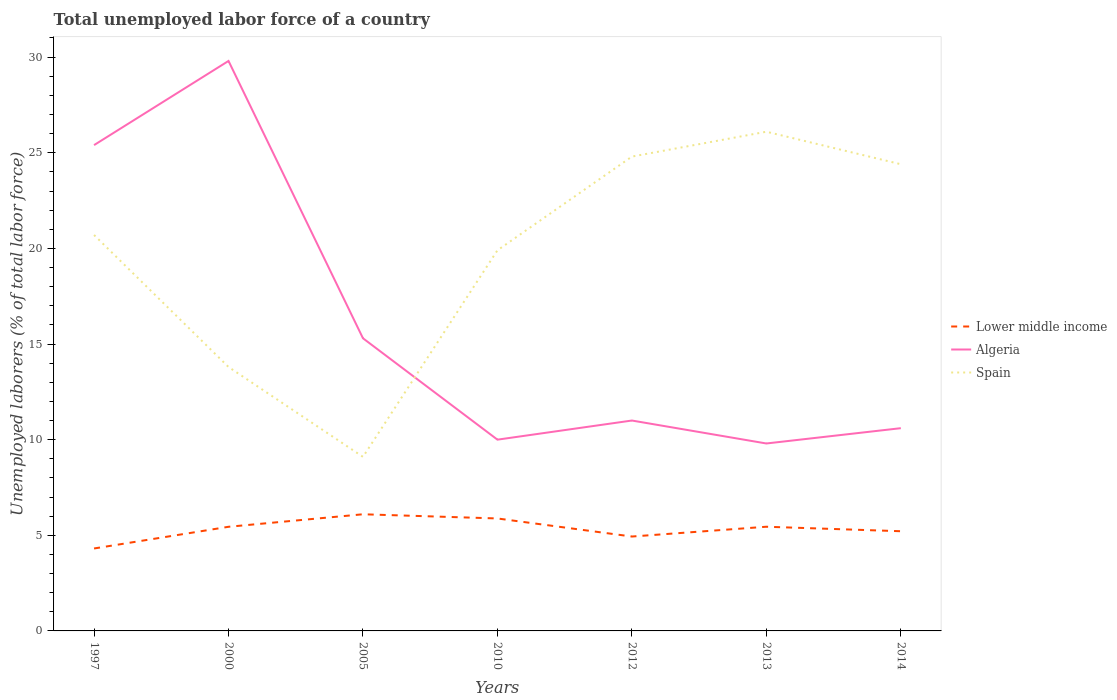Is the number of lines equal to the number of legend labels?
Ensure brevity in your answer.  Yes. Across all years, what is the maximum total unemployed labor force in Spain?
Offer a very short reply. 9.1. What is the total total unemployed labor force in Lower middle income in the graph?
Your answer should be very brief. 0.22. What is the difference between the highest and the second highest total unemployed labor force in Spain?
Provide a succinct answer. 17. What is the difference between the highest and the lowest total unemployed labor force in Algeria?
Offer a terse response. 2. How many lines are there?
Provide a short and direct response. 3. Are the values on the major ticks of Y-axis written in scientific E-notation?
Make the answer very short. No. Does the graph contain grids?
Keep it short and to the point. No. How are the legend labels stacked?
Provide a succinct answer. Vertical. What is the title of the graph?
Make the answer very short. Total unemployed labor force of a country. What is the label or title of the X-axis?
Your answer should be compact. Years. What is the label or title of the Y-axis?
Keep it short and to the point. Unemployed laborers (% of total labor force). What is the Unemployed laborers (% of total labor force) in Lower middle income in 1997?
Provide a short and direct response. 4.31. What is the Unemployed laborers (% of total labor force) in Algeria in 1997?
Offer a terse response. 25.4. What is the Unemployed laborers (% of total labor force) of Spain in 1997?
Your answer should be very brief. 20.7. What is the Unemployed laborers (% of total labor force) of Lower middle income in 2000?
Your answer should be very brief. 5.44. What is the Unemployed laborers (% of total labor force) in Algeria in 2000?
Provide a succinct answer. 29.8. What is the Unemployed laborers (% of total labor force) in Spain in 2000?
Ensure brevity in your answer.  13.8. What is the Unemployed laborers (% of total labor force) in Lower middle income in 2005?
Ensure brevity in your answer.  6.1. What is the Unemployed laborers (% of total labor force) in Algeria in 2005?
Provide a succinct answer. 15.3. What is the Unemployed laborers (% of total labor force) of Spain in 2005?
Give a very brief answer. 9.1. What is the Unemployed laborers (% of total labor force) of Lower middle income in 2010?
Your answer should be compact. 5.88. What is the Unemployed laborers (% of total labor force) in Spain in 2010?
Give a very brief answer. 19.9. What is the Unemployed laborers (% of total labor force) in Lower middle income in 2012?
Offer a very short reply. 4.93. What is the Unemployed laborers (% of total labor force) in Spain in 2012?
Make the answer very short. 24.8. What is the Unemployed laborers (% of total labor force) of Lower middle income in 2013?
Your answer should be compact. 5.45. What is the Unemployed laborers (% of total labor force) in Algeria in 2013?
Ensure brevity in your answer.  9.8. What is the Unemployed laborers (% of total labor force) in Spain in 2013?
Give a very brief answer. 26.1. What is the Unemployed laborers (% of total labor force) of Lower middle income in 2014?
Provide a succinct answer. 5.21. What is the Unemployed laborers (% of total labor force) of Algeria in 2014?
Provide a short and direct response. 10.6. What is the Unemployed laborers (% of total labor force) in Spain in 2014?
Give a very brief answer. 24.4. Across all years, what is the maximum Unemployed laborers (% of total labor force) of Lower middle income?
Keep it short and to the point. 6.1. Across all years, what is the maximum Unemployed laborers (% of total labor force) in Algeria?
Keep it short and to the point. 29.8. Across all years, what is the maximum Unemployed laborers (% of total labor force) in Spain?
Offer a terse response. 26.1. Across all years, what is the minimum Unemployed laborers (% of total labor force) of Lower middle income?
Provide a short and direct response. 4.31. Across all years, what is the minimum Unemployed laborers (% of total labor force) in Algeria?
Your answer should be very brief. 9.8. Across all years, what is the minimum Unemployed laborers (% of total labor force) in Spain?
Provide a short and direct response. 9.1. What is the total Unemployed laborers (% of total labor force) of Lower middle income in the graph?
Give a very brief answer. 37.33. What is the total Unemployed laborers (% of total labor force) in Algeria in the graph?
Your answer should be very brief. 111.9. What is the total Unemployed laborers (% of total labor force) of Spain in the graph?
Your answer should be compact. 138.8. What is the difference between the Unemployed laborers (% of total labor force) of Lower middle income in 1997 and that in 2000?
Offer a terse response. -1.13. What is the difference between the Unemployed laborers (% of total labor force) of Lower middle income in 1997 and that in 2005?
Your response must be concise. -1.79. What is the difference between the Unemployed laborers (% of total labor force) in Algeria in 1997 and that in 2005?
Give a very brief answer. 10.1. What is the difference between the Unemployed laborers (% of total labor force) of Lower middle income in 1997 and that in 2010?
Your response must be concise. -1.57. What is the difference between the Unemployed laborers (% of total labor force) of Spain in 1997 and that in 2010?
Provide a succinct answer. 0.8. What is the difference between the Unemployed laborers (% of total labor force) of Lower middle income in 1997 and that in 2012?
Your response must be concise. -0.62. What is the difference between the Unemployed laborers (% of total labor force) in Lower middle income in 1997 and that in 2013?
Keep it short and to the point. -1.14. What is the difference between the Unemployed laborers (% of total labor force) of Algeria in 1997 and that in 2013?
Your answer should be very brief. 15.6. What is the difference between the Unemployed laborers (% of total labor force) in Spain in 1997 and that in 2013?
Ensure brevity in your answer.  -5.4. What is the difference between the Unemployed laborers (% of total labor force) in Lower middle income in 1997 and that in 2014?
Offer a terse response. -0.9. What is the difference between the Unemployed laborers (% of total labor force) in Algeria in 1997 and that in 2014?
Provide a succinct answer. 14.8. What is the difference between the Unemployed laborers (% of total labor force) in Lower middle income in 2000 and that in 2005?
Offer a very short reply. -0.65. What is the difference between the Unemployed laborers (% of total labor force) of Lower middle income in 2000 and that in 2010?
Provide a succinct answer. -0.43. What is the difference between the Unemployed laborers (% of total labor force) in Algeria in 2000 and that in 2010?
Your answer should be compact. 19.8. What is the difference between the Unemployed laborers (% of total labor force) of Spain in 2000 and that in 2010?
Your response must be concise. -6.1. What is the difference between the Unemployed laborers (% of total labor force) in Lower middle income in 2000 and that in 2012?
Offer a very short reply. 0.51. What is the difference between the Unemployed laborers (% of total labor force) of Spain in 2000 and that in 2012?
Provide a short and direct response. -11. What is the difference between the Unemployed laborers (% of total labor force) of Lower middle income in 2000 and that in 2013?
Your response must be concise. -0. What is the difference between the Unemployed laborers (% of total labor force) of Algeria in 2000 and that in 2013?
Keep it short and to the point. 20. What is the difference between the Unemployed laborers (% of total labor force) of Lower middle income in 2000 and that in 2014?
Make the answer very short. 0.23. What is the difference between the Unemployed laborers (% of total labor force) in Algeria in 2000 and that in 2014?
Offer a very short reply. 19.2. What is the difference between the Unemployed laborers (% of total labor force) in Lower middle income in 2005 and that in 2010?
Your answer should be very brief. 0.22. What is the difference between the Unemployed laborers (% of total labor force) of Lower middle income in 2005 and that in 2012?
Offer a very short reply. 1.16. What is the difference between the Unemployed laborers (% of total labor force) of Algeria in 2005 and that in 2012?
Make the answer very short. 4.3. What is the difference between the Unemployed laborers (% of total labor force) of Spain in 2005 and that in 2012?
Ensure brevity in your answer.  -15.7. What is the difference between the Unemployed laborers (% of total labor force) in Lower middle income in 2005 and that in 2013?
Offer a very short reply. 0.65. What is the difference between the Unemployed laborers (% of total labor force) of Spain in 2005 and that in 2013?
Your response must be concise. -17. What is the difference between the Unemployed laborers (% of total labor force) in Lower middle income in 2005 and that in 2014?
Offer a very short reply. 0.89. What is the difference between the Unemployed laborers (% of total labor force) in Algeria in 2005 and that in 2014?
Make the answer very short. 4.7. What is the difference between the Unemployed laborers (% of total labor force) in Spain in 2005 and that in 2014?
Your response must be concise. -15.3. What is the difference between the Unemployed laborers (% of total labor force) in Lower middle income in 2010 and that in 2012?
Provide a succinct answer. 0.94. What is the difference between the Unemployed laborers (% of total labor force) of Algeria in 2010 and that in 2012?
Make the answer very short. -1. What is the difference between the Unemployed laborers (% of total labor force) of Lower middle income in 2010 and that in 2013?
Provide a succinct answer. 0.43. What is the difference between the Unemployed laborers (% of total labor force) of Algeria in 2010 and that in 2013?
Offer a terse response. 0.2. What is the difference between the Unemployed laborers (% of total labor force) of Lower middle income in 2010 and that in 2014?
Ensure brevity in your answer.  0.67. What is the difference between the Unemployed laborers (% of total labor force) of Algeria in 2010 and that in 2014?
Provide a succinct answer. -0.6. What is the difference between the Unemployed laborers (% of total labor force) in Spain in 2010 and that in 2014?
Give a very brief answer. -4.5. What is the difference between the Unemployed laborers (% of total labor force) in Lower middle income in 2012 and that in 2013?
Your response must be concise. -0.51. What is the difference between the Unemployed laborers (% of total labor force) in Lower middle income in 2012 and that in 2014?
Make the answer very short. -0.28. What is the difference between the Unemployed laborers (% of total labor force) of Algeria in 2012 and that in 2014?
Provide a short and direct response. 0.4. What is the difference between the Unemployed laborers (% of total labor force) in Spain in 2012 and that in 2014?
Make the answer very short. 0.4. What is the difference between the Unemployed laborers (% of total labor force) of Lower middle income in 2013 and that in 2014?
Your response must be concise. 0.23. What is the difference between the Unemployed laborers (% of total labor force) in Algeria in 2013 and that in 2014?
Offer a terse response. -0.8. What is the difference between the Unemployed laborers (% of total labor force) of Spain in 2013 and that in 2014?
Ensure brevity in your answer.  1.7. What is the difference between the Unemployed laborers (% of total labor force) of Lower middle income in 1997 and the Unemployed laborers (% of total labor force) of Algeria in 2000?
Your response must be concise. -25.49. What is the difference between the Unemployed laborers (% of total labor force) of Lower middle income in 1997 and the Unemployed laborers (% of total labor force) of Spain in 2000?
Ensure brevity in your answer.  -9.49. What is the difference between the Unemployed laborers (% of total labor force) in Lower middle income in 1997 and the Unemployed laborers (% of total labor force) in Algeria in 2005?
Offer a terse response. -10.99. What is the difference between the Unemployed laborers (% of total labor force) in Lower middle income in 1997 and the Unemployed laborers (% of total labor force) in Spain in 2005?
Your answer should be compact. -4.79. What is the difference between the Unemployed laborers (% of total labor force) in Algeria in 1997 and the Unemployed laborers (% of total labor force) in Spain in 2005?
Provide a short and direct response. 16.3. What is the difference between the Unemployed laborers (% of total labor force) of Lower middle income in 1997 and the Unemployed laborers (% of total labor force) of Algeria in 2010?
Offer a terse response. -5.69. What is the difference between the Unemployed laborers (% of total labor force) of Lower middle income in 1997 and the Unemployed laborers (% of total labor force) of Spain in 2010?
Your answer should be compact. -15.59. What is the difference between the Unemployed laborers (% of total labor force) in Lower middle income in 1997 and the Unemployed laborers (% of total labor force) in Algeria in 2012?
Offer a very short reply. -6.69. What is the difference between the Unemployed laborers (% of total labor force) in Lower middle income in 1997 and the Unemployed laborers (% of total labor force) in Spain in 2012?
Your response must be concise. -20.49. What is the difference between the Unemployed laborers (% of total labor force) of Lower middle income in 1997 and the Unemployed laborers (% of total labor force) of Algeria in 2013?
Provide a short and direct response. -5.49. What is the difference between the Unemployed laborers (% of total labor force) in Lower middle income in 1997 and the Unemployed laborers (% of total labor force) in Spain in 2013?
Your response must be concise. -21.79. What is the difference between the Unemployed laborers (% of total labor force) in Lower middle income in 1997 and the Unemployed laborers (% of total labor force) in Algeria in 2014?
Your response must be concise. -6.29. What is the difference between the Unemployed laborers (% of total labor force) in Lower middle income in 1997 and the Unemployed laborers (% of total labor force) in Spain in 2014?
Your response must be concise. -20.09. What is the difference between the Unemployed laborers (% of total labor force) in Algeria in 1997 and the Unemployed laborers (% of total labor force) in Spain in 2014?
Provide a short and direct response. 1. What is the difference between the Unemployed laborers (% of total labor force) of Lower middle income in 2000 and the Unemployed laborers (% of total labor force) of Algeria in 2005?
Your response must be concise. -9.86. What is the difference between the Unemployed laborers (% of total labor force) in Lower middle income in 2000 and the Unemployed laborers (% of total labor force) in Spain in 2005?
Provide a succinct answer. -3.66. What is the difference between the Unemployed laborers (% of total labor force) of Algeria in 2000 and the Unemployed laborers (% of total labor force) of Spain in 2005?
Make the answer very short. 20.7. What is the difference between the Unemployed laborers (% of total labor force) of Lower middle income in 2000 and the Unemployed laborers (% of total labor force) of Algeria in 2010?
Keep it short and to the point. -4.56. What is the difference between the Unemployed laborers (% of total labor force) of Lower middle income in 2000 and the Unemployed laborers (% of total labor force) of Spain in 2010?
Offer a very short reply. -14.46. What is the difference between the Unemployed laborers (% of total labor force) of Lower middle income in 2000 and the Unemployed laborers (% of total labor force) of Algeria in 2012?
Offer a terse response. -5.56. What is the difference between the Unemployed laborers (% of total labor force) in Lower middle income in 2000 and the Unemployed laborers (% of total labor force) in Spain in 2012?
Provide a succinct answer. -19.36. What is the difference between the Unemployed laborers (% of total labor force) in Algeria in 2000 and the Unemployed laborers (% of total labor force) in Spain in 2012?
Your answer should be compact. 5. What is the difference between the Unemployed laborers (% of total labor force) of Lower middle income in 2000 and the Unemployed laborers (% of total labor force) of Algeria in 2013?
Provide a short and direct response. -4.36. What is the difference between the Unemployed laborers (% of total labor force) in Lower middle income in 2000 and the Unemployed laborers (% of total labor force) in Spain in 2013?
Make the answer very short. -20.66. What is the difference between the Unemployed laborers (% of total labor force) of Lower middle income in 2000 and the Unemployed laborers (% of total labor force) of Algeria in 2014?
Provide a short and direct response. -5.16. What is the difference between the Unemployed laborers (% of total labor force) of Lower middle income in 2000 and the Unemployed laborers (% of total labor force) of Spain in 2014?
Offer a terse response. -18.96. What is the difference between the Unemployed laborers (% of total labor force) of Lower middle income in 2005 and the Unemployed laborers (% of total labor force) of Algeria in 2010?
Ensure brevity in your answer.  -3.9. What is the difference between the Unemployed laborers (% of total labor force) in Lower middle income in 2005 and the Unemployed laborers (% of total labor force) in Spain in 2010?
Your answer should be compact. -13.8. What is the difference between the Unemployed laborers (% of total labor force) of Lower middle income in 2005 and the Unemployed laborers (% of total labor force) of Algeria in 2012?
Offer a very short reply. -4.9. What is the difference between the Unemployed laborers (% of total labor force) of Lower middle income in 2005 and the Unemployed laborers (% of total labor force) of Spain in 2012?
Keep it short and to the point. -18.7. What is the difference between the Unemployed laborers (% of total labor force) of Algeria in 2005 and the Unemployed laborers (% of total labor force) of Spain in 2012?
Give a very brief answer. -9.5. What is the difference between the Unemployed laborers (% of total labor force) in Lower middle income in 2005 and the Unemployed laborers (% of total labor force) in Algeria in 2013?
Make the answer very short. -3.7. What is the difference between the Unemployed laborers (% of total labor force) of Lower middle income in 2005 and the Unemployed laborers (% of total labor force) of Spain in 2013?
Offer a terse response. -20. What is the difference between the Unemployed laborers (% of total labor force) of Lower middle income in 2005 and the Unemployed laborers (% of total labor force) of Algeria in 2014?
Your response must be concise. -4.5. What is the difference between the Unemployed laborers (% of total labor force) in Lower middle income in 2005 and the Unemployed laborers (% of total labor force) in Spain in 2014?
Your response must be concise. -18.3. What is the difference between the Unemployed laborers (% of total labor force) in Algeria in 2005 and the Unemployed laborers (% of total labor force) in Spain in 2014?
Keep it short and to the point. -9.1. What is the difference between the Unemployed laborers (% of total labor force) of Lower middle income in 2010 and the Unemployed laborers (% of total labor force) of Algeria in 2012?
Your answer should be very brief. -5.12. What is the difference between the Unemployed laborers (% of total labor force) of Lower middle income in 2010 and the Unemployed laborers (% of total labor force) of Spain in 2012?
Your response must be concise. -18.92. What is the difference between the Unemployed laborers (% of total labor force) in Algeria in 2010 and the Unemployed laborers (% of total labor force) in Spain in 2012?
Keep it short and to the point. -14.8. What is the difference between the Unemployed laborers (% of total labor force) of Lower middle income in 2010 and the Unemployed laborers (% of total labor force) of Algeria in 2013?
Your response must be concise. -3.92. What is the difference between the Unemployed laborers (% of total labor force) of Lower middle income in 2010 and the Unemployed laborers (% of total labor force) of Spain in 2013?
Give a very brief answer. -20.22. What is the difference between the Unemployed laborers (% of total labor force) of Algeria in 2010 and the Unemployed laborers (% of total labor force) of Spain in 2013?
Provide a short and direct response. -16.1. What is the difference between the Unemployed laborers (% of total labor force) of Lower middle income in 2010 and the Unemployed laborers (% of total labor force) of Algeria in 2014?
Provide a short and direct response. -4.72. What is the difference between the Unemployed laborers (% of total labor force) of Lower middle income in 2010 and the Unemployed laborers (% of total labor force) of Spain in 2014?
Keep it short and to the point. -18.52. What is the difference between the Unemployed laborers (% of total labor force) of Algeria in 2010 and the Unemployed laborers (% of total labor force) of Spain in 2014?
Your answer should be very brief. -14.4. What is the difference between the Unemployed laborers (% of total labor force) in Lower middle income in 2012 and the Unemployed laborers (% of total labor force) in Algeria in 2013?
Ensure brevity in your answer.  -4.87. What is the difference between the Unemployed laborers (% of total labor force) in Lower middle income in 2012 and the Unemployed laborers (% of total labor force) in Spain in 2013?
Your answer should be compact. -21.17. What is the difference between the Unemployed laborers (% of total labor force) in Algeria in 2012 and the Unemployed laborers (% of total labor force) in Spain in 2013?
Your answer should be compact. -15.1. What is the difference between the Unemployed laborers (% of total labor force) in Lower middle income in 2012 and the Unemployed laborers (% of total labor force) in Algeria in 2014?
Provide a short and direct response. -5.67. What is the difference between the Unemployed laborers (% of total labor force) in Lower middle income in 2012 and the Unemployed laborers (% of total labor force) in Spain in 2014?
Keep it short and to the point. -19.47. What is the difference between the Unemployed laborers (% of total labor force) of Lower middle income in 2013 and the Unemployed laborers (% of total labor force) of Algeria in 2014?
Keep it short and to the point. -5.15. What is the difference between the Unemployed laborers (% of total labor force) in Lower middle income in 2013 and the Unemployed laborers (% of total labor force) in Spain in 2014?
Provide a short and direct response. -18.95. What is the difference between the Unemployed laborers (% of total labor force) of Algeria in 2013 and the Unemployed laborers (% of total labor force) of Spain in 2014?
Keep it short and to the point. -14.6. What is the average Unemployed laborers (% of total labor force) in Lower middle income per year?
Your response must be concise. 5.33. What is the average Unemployed laborers (% of total labor force) of Algeria per year?
Make the answer very short. 15.99. What is the average Unemployed laborers (% of total labor force) in Spain per year?
Your response must be concise. 19.83. In the year 1997, what is the difference between the Unemployed laborers (% of total labor force) in Lower middle income and Unemployed laborers (% of total labor force) in Algeria?
Your answer should be compact. -21.09. In the year 1997, what is the difference between the Unemployed laborers (% of total labor force) of Lower middle income and Unemployed laborers (% of total labor force) of Spain?
Your answer should be compact. -16.39. In the year 1997, what is the difference between the Unemployed laborers (% of total labor force) in Algeria and Unemployed laborers (% of total labor force) in Spain?
Provide a short and direct response. 4.7. In the year 2000, what is the difference between the Unemployed laborers (% of total labor force) in Lower middle income and Unemployed laborers (% of total labor force) in Algeria?
Provide a succinct answer. -24.36. In the year 2000, what is the difference between the Unemployed laborers (% of total labor force) in Lower middle income and Unemployed laborers (% of total labor force) in Spain?
Give a very brief answer. -8.36. In the year 2005, what is the difference between the Unemployed laborers (% of total labor force) of Lower middle income and Unemployed laborers (% of total labor force) of Algeria?
Give a very brief answer. -9.2. In the year 2005, what is the difference between the Unemployed laborers (% of total labor force) of Lower middle income and Unemployed laborers (% of total labor force) of Spain?
Give a very brief answer. -3. In the year 2005, what is the difference between the Unemployed laborers (% of total labor force) of Algeria and Unemployed laborers (% of total labor force) of Spain?
Offer a terse response. 6.2. In the year 2010, what is the difference between the Unemployed laborers (% of total labor force) of Lower middle income and Unemployed laborers (% of total labor force) of Algeria?
Your answer should be very brief. -4.12. In the year 2010, what is the difference between the Unemployed laborers (% of total labor force) in Lower middle income and Unemployed laborers (% of total labor force) in Spain?
Provide a short and direct response. -14.02. In the year 2010, what is the difference between the Unemployed laborers (% of total labor force) in Algeria and Unemployed laborers (% of total labor force) in Spain?
Your answer should be compact. -9.9. In the year 2012, what is the difference between the Unemployed laborers (% of total labor force) in Lower middle income and Unemployed laborers (% of total labor force) in Algeria?
Make the answer very short. -6.07. In the year 2012, what is the difference between the Unemployed laborers (% of total labor force) in Lower middle income and Unemployed laborers (% of total labor force) in Spain?
Offer a terse response. -19.87. In the year 2013, what is the difference between the Unemployed laborers (% of total labor force) in Lower middle income and Unemployed laborers (% of total labor force) in Algeria?
Your answer should be very brief. -4.35. In the year 2013, what is the difference between the Unemployed laborers (% of total labor force) of Lower middle income and Unemployed laborers (% of total labor force) of Spain?
Offer a very short reply. -20.65. In the year 2013, what is the difference between the Unemployed laborers (% of total labor force) in Algeria and Unemployed laborers (% of total labor force) in Spain?
Your answer should be compact. -16.3. In the year 2014, what is the difference between the Unemployed laborers (% of total labor force) in Lower middle income and Unemployed laborers (% of total labor force) in Algeria?
Offer a terse response. -5.39. In the year 2014, what is the difference between the Unemployed laborers (% of total labor force) of Lower middle income and Unemployed laborers (% of total labor force) of Spain?
Offer a very short reply. -19.19. In the year 2014, what is the difference between the Unemployed laborers (% of total labor force) in Algeria and Unemployed laborers (% of total labor force) in Spain?
Your response must be concise. -13.8. What is the ratio of the Unemployed laborers (% of total labor force) of Lower middle income in 1997 to that in 2000?
Provide a short and direct response. 0.79. What is the ratio of the Unemployed laborers (% of total labor force) in Algeria in 1997 to that in 2000?
Ensure brevity in your answer.  0.85. What is the ratio of the Unemployed laborers (% of total labor force) of Lower middle income in 1997 to that in 2005?
Ensure brevity in your answer.  0.71. What is the ratio of the Unemployed laborers (% of total labor force) in Algeria in 1997 to that in 2005?
Give a very brief answer. 1.66. What is the ratio of the Unemployed laborers (% of total labor force) in Spain in 1997 to that in 2005?
Make the answer very short. 2.27. What is the ratio of the Unemployed laborers (% of total labor force) of Lower middle income in 1997 to that in 2010?
Your answer should be compact. 0.73. What is the ratio of the Unemployed laborers (% of total labor force) in Algeria in 1997 to that in 2010?
Make the answer very short. 2.54. What is the ratio of the Unemployed laborers (% of total labor force) of Spain in 1997 to that in 2010?
Give a very brief answer. 1.04. What is the ratio of the Unemployed laborers (% of total labor force) in Lower middle income in 1997 to that in 2012?
Provide a succinct answer. 0.87. What is the ratio of the Unemployed laborers (% of total labor force) in Algeria in 1997 to that in 2012?
Make the answer very short. 2.31. What is the ratio of the Unemployed laborers (% of total labor force) in Spain in 1997 to that in 2012?
Your answer should be compact. 0.83. What is the ratio of the Unemployed laborers (% of total labor force) in Lower middle income in 1997 to that in 2013?
Your answer should be very brief. 0.79. What is the ratio of the Unemployed laborers (% of total labor force) of Algeria in 1997 to that in 2013?
Give a very brief answer. 2.59. What is the ratio of the Unemployed laborers (% of total labor force) of Spain in 1997 to that in 2013?
Keep it short and to the point. 0.79. What is the ratio of the Unemployed laborers (% of total labor force) of Lower middle income in 1997 to that in 2014?
Offer a very short reply. 0.83. What is the ratio of the Unemployed laborers (% of total labor force) in Algeria in 1997 to that in 2014?
Your answer should be very brief. 2.4. What is the ratio of the Unemployed laborers (% of total labor force) in Spain in 1997 to that in 2014?
Keep it short and to the point. 0.85. What is the ratio of the Unemployed laborers (% of total labor force) of Lower middle income in 2000 to that in 2005?
Keep it short and to the point. 0.89. What is the ratio of the Unemployed laborers (% of total labor force) in Algeria in 2000 to that in 2005?
Provide a short and direct response. 1.95. What is the ratio of the Unemployed laborers (% of total labor force) in Spain in 2000 to that in 2005?
Provide a short and direct response. 1.52. What is the ratio of the Unemployed laborers (% of total labor force) of Lower middle income in 2000 to that in 2010?
Offer a very short reply. 0.93. What is the ratio of the Unemployed laborers (% of total labor force) of Algeria in 2000 to that in 2010?
Ensure brevity in your answer.  2.98. What is the ratio of the Unemployed laborers (% of total labor force) in Spain in 2000 to that in 2010?
Give a very brief answer. 0.69. What is the ratio of the Unemployed laborers (% of total labor force) in Lower middle income in 2000 to that in 2012?
Keep it short and to the point. 1.1. What is the ratio of the Unemployed laborers (% of total labor force) of Algeria in 2000 to that in 2012?
Make the answer very short. 2.71. What is the ratio of the Unemployed laborers (% of total labor force) in Spain in 2000 to that in 2012?
Make the answer very short. 0.56. What is the ratio of the Unemployed laborers (% of total labor force) of Algeria in 2000 to that in 2013?
Offer a terse response. 3.04. What is the ratio of the Unemployed laborers (% of total labor force) of Spain in 2000 to that in 2013?
Make the answer very short. 0.53. What is the ratio of the Unemployed laborers (% of total labor force) in Lower middle income in 2000 to that in 2014?
Offer a very short reply. 1.04. What is the ratio of the Unemployed laborers (% of total labor force) in Algeria in 2000 to that in 2014?
Your response must be concise. 2.81. What is the ratio of the Unemployed laborers (% of total labor force) of Spain in 2000 to that in 2014?
Your answer should be very brief. 0.57. What is the ratio of the Unemployed laborers (% of total labor force) in Lower middle income in 2005 to that in 2010?
Offer a terse response. 1.04. What is the ratio of the Unemployed laborers (% of total labor force) in Algeria in 2005 to that in 2010?
Make the answer very short. 1.53. What is the ratio of the Unemployed laborers (% of total labor force) of Spain in 2005 to that in 2010?
Your answer should be very brief. 0.46. What is the ratio of the Unemployed laborers (% of total labor force) of Lower middle income in 2005 to that in 2012?
Offer a terse response. 1.24. What is the ratio of the Unemployed laborers (% of total labor force) of Algeria in 2005 to that in 2012?
Ensure brevity in your answer.  1.39. What is the ratio of the Unemployed laborers (% of total labor force) in Spain in 2005 to that in 2012?
Your answer should be very brief. 0.37. What is the ratio of the Unemployed laborers (% of total labor force) in Lower middle income in 2005 to that in 2013?
Give a very brief answer. 1.12. What is the ratio of the Unemployed laborers (% of total labor force) of Algeria in 2005 to that in 2013?
Give a very brief answer. 1.56. What is the ratio of the Unemployed laborers (% of total labor force) in Spain in 2005 to that in 2013?
Ensure brevity in your answer.  0.35. What is the ratio of the Unemployed laborers (% of total labor force) in Lower middle income in 2005 to that in 2014?
Provide a short and direct response. 1.17. What is the ratio of the Unemployed laborers (% of total labor force) in Algeria in 2005 to that in 2014?
Provide a succinct answer. 1.44. What is the ratio of the Unemployed laborers (% of total labor force) of Spain in 2005 to that in 2014?
Your answer should be compact. 0.37. What is the ratio of the Unemployed laborers (% of total labor force) in Lower middle income in 2010 to that in 2012?
Your answer should be very brief. 1.19. What is the ratio of the Unemployed laborers (% of total labor force) of Algeria in 2010 to that in 2012?
Keep it short and to the point. 0.91. What is the ratio of the Unemployed laborers (% of total labor force) of Spain in 2010 to that in 2012?
Offer a very short reply. 0.8. What is the ratio of the Unemployed laborers (% of total labor force) of Lower middle income in 2010 to that in 2013?
Your answer should be compact. 1.08. What is the ratio of the Unemployed laborers (% of total labor force) of Algeria in 2010 to that in 2013?
Keep it short and to the point. 1.02. What is the ratio of the Unemployed laborers (% of total labor force) in Spain in 2010 to that in 2013?
Your answer should be very brief. 0.76. What is the ratio of the Unemployed laborers (% of total labor force) in Lower middle income in 2010 to that in 2014?
Offer a very short reply. 1.13. What is the ratio of the Unemployed laborers (% of total labor force) of Algeria in 2010 to that in 2014?
Provide a short and direct response. 0.94. What is the ratio of the Unemployed laborers (% of total labor force) of Spain in 2010 to that in 2014?
Offer a terse response. 0.82. What is the ratio of the Unemployed laborers (% of total labor force) of Lower middle income in 2012 to that in 2013?
Your answer should be very brief. 0.91. What is the ratio of the Unemployed laborers (% of total labor force) in Algeria in 2012 to that in 2013?
Give a very brief answer. 1.12. What is the ratio of the Unemployed laborers (% of total labor force) in Spain in 2012 to that in 2013?
Your answer should be very brief. 0.95. What is the ratio of the Unemployed laborers (% of total labor force) of Lower middle income in 2012 to that in 2014?
Your answer should be compact. 0.95. What is the ratio of the Unemployed laborers (% of total labor force) of Algeria in 2012 to that in 2014?
Keep it short and to the point. 1.04. What is the ratio of the Unemployed laborers (% of total labor force) of Spain in 2012 to that in 2014?
Ensure brevity in your answer.  1.02. What is the ratio of the Unemployed laborers (% of total labor force) in Lower middle income in 2013 to that in 2014?
Provide a succinct answer. 1.04. What is the ratio of the Unemployed laborers (% of total labor force) of Algeria in 2013 to that in 2014?
Give a very brief answer. 0.92. What is the ratio of the Unemployed laborers (% of total labor force) in Spain in 2013 to that in 2014?
Make the answer very short. 1.07. What is the difference between the highest and the second highest Unemployed laborers (% of total labor force) in Lower middle income?
Make the answer very short. 0.22. What is the difference between the highest and the second highest Unemployed laborers (% of total labor force) in Spain?
Make the answer very short. 1.3. What is the difference between the highest and the lowest Unemployed laborers (% of total labor force) of Lower middle income?
Your answer should be very brief. 1.79. What is the difference between the highest and the lowest Unemployed laborers (% of total labor force) of Algeria?
Provide a succinct answer. 20. 